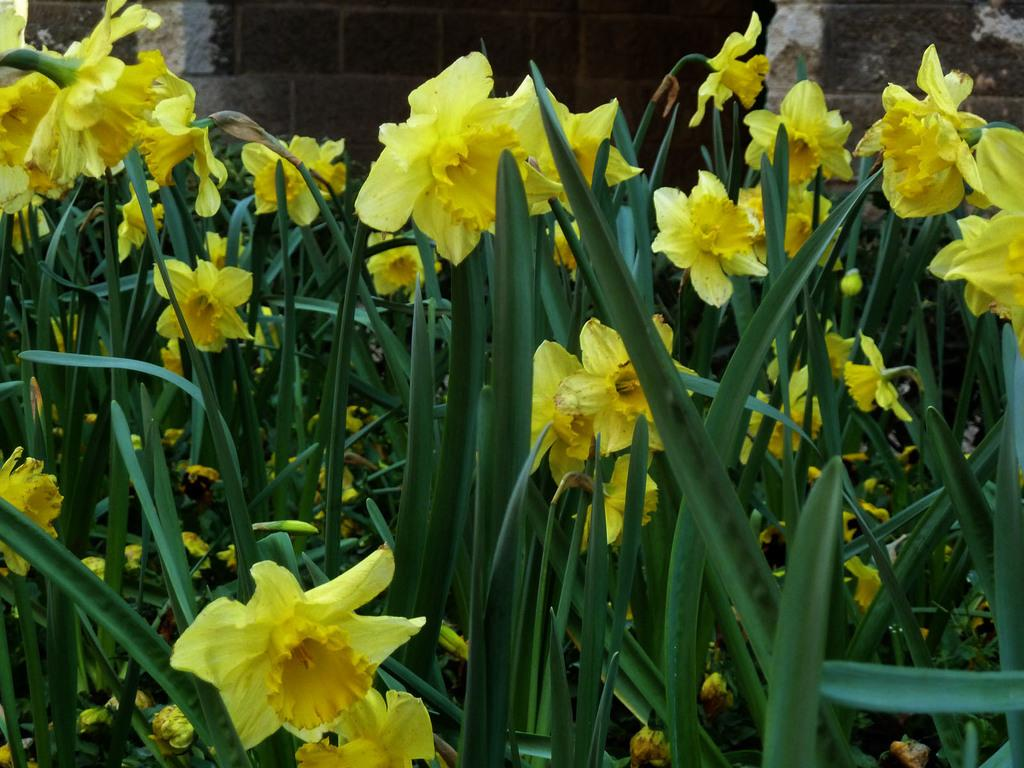What type of plants are in the foreground of the image? There are flowering plants in the foreground of the image. What can be seen in the background of the image? There is a wall visible in the background of the image. What type of locket is hanging from the wall in the image? There is no locket present in the image; only flowering plants and a wall are visible. 